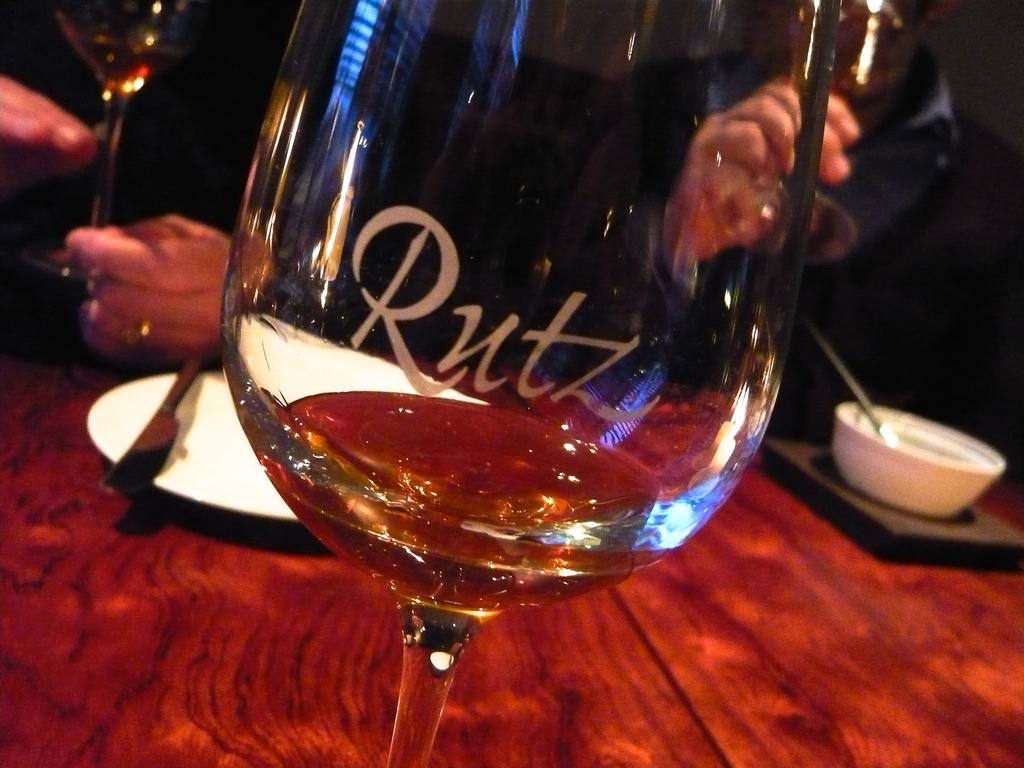What is located at the bottom of the image? There is a table at the bottom of the image. What objects can be seen on the table? There is a glass, a plate, a knife, a bowl, and a spoon on the table. Is there anyone present in the image? Yes, there is a person standing behind the table. Where is the playground located in the image? There is no playground present in the image. What is the person doing with their thumb in the image? There is no indication of the person using their thumb in the image. 